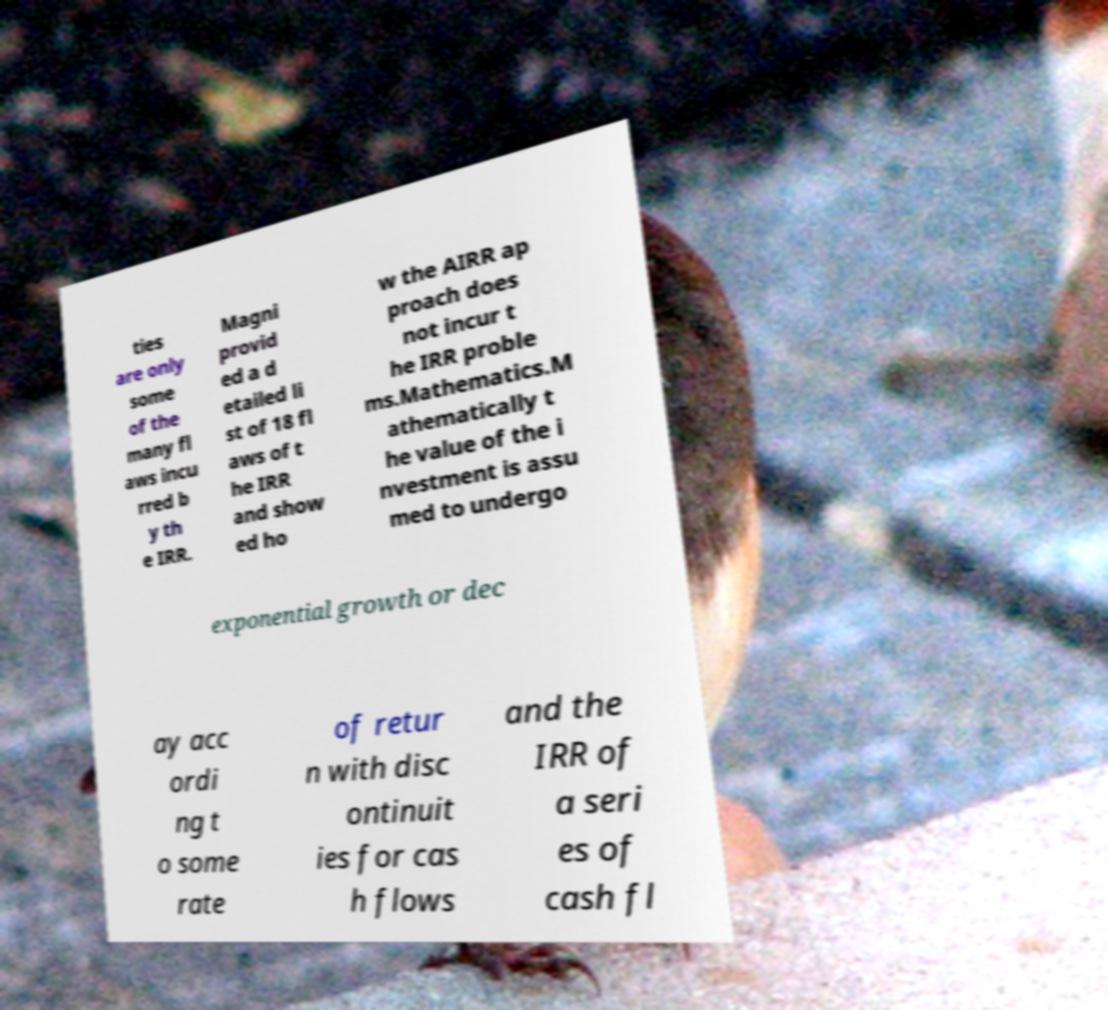Please identify and transcribe the text found in this image. ties are only some of the many fl aws incu rred b y th e IRR. Magni provid ed a d etailed li st of 18 fl aws of t he IRR and show ed ho w the AIRR ap proach does not incur t he IRR proble ms.Mathematics.M athematically t he value of the i nvestment is assu med to undergo exponential growth or dec ay acc ordi ng t o some rate of retur n with disc ontinuit ies for cas h flows and the IRR of a seri es of cash fl 